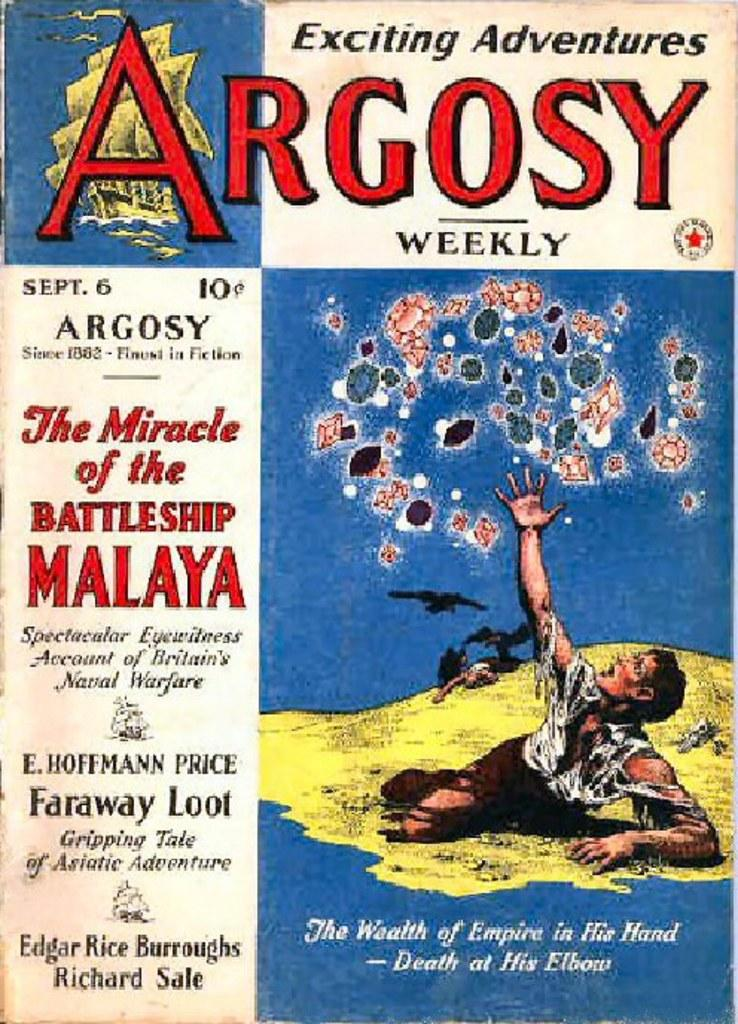<image>
Give a short and clear explanation of the subsequent image. Cover for "Exciting Adventures Argosy" showing a man struggling. 